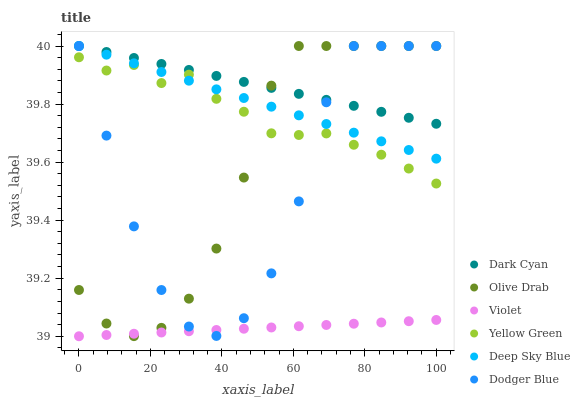Does Violet have the minimum area under the curve?
Answer yes or no. Yes. Does Dark Cyan have the maximum area under the curve?
Answer yes or no. Yes. Does Dodger Blue have the minimum area under the curve?
Answer yes or no. No. Does Dodger Blue have the maximum area under the curve?
Answer yes or no. No. Is Deep Sky Blue the smoothest?
Answer yes or no. Yes. Is Dodger Blue the roughest?
Answer yes or no. Yes. Is Dodger Blue the smoothest?
Answer yes or no. No. Is Deep Sky Blue the roughest?
Answer yes or no. No. Does Violet have the lowest value?
Answer yes or no. Yes. Does Dodger Blue have the lowest value?
Answer yes or no. No. Does Olive Drab have the highest value?
Answer yes or no. Yes. Does Violet have the highest value?
Answer yes or no. No. Is Violet less than Deep Sky Blue?
Answer yes or no. Yes. Is Yellow Green greater than Violet?
Answer yes or no. Yes. Does Violet intersect Olive Drab?
Answer yes or no. Yes. Is Violet less than Olive Drab?
Answer yes or no. No. Is Violet greater than Olive Drab?
Answer yes or no. No. Does Violet intersect Deep Sky Blue?
Answer yes or no. No. 